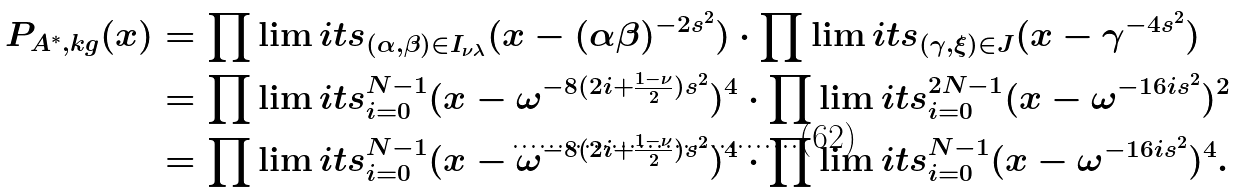Convert formula to latex. <formula><loc_0><loc_0><loc_500><loc_500>P _ { A ^ { \ast } , k g } ( x ) & = \prod \lim i t s _ { ( \alpha , \beta ) \in I _ { \nu \lambda } } ( x - ( \alpha \beta ) ^ { - 2 s ^ { 2 } } ) \cdot \prod \lim i t s _ { ( \gamma , \xi ) \in J } ( x - \gamma ^ { - 4 s ^ { 2 } } ) \\ & = \prod \lim i t s _ { i = 0 } ^ { N - 1 } ( x - \omega ^ { - 8 ( 2 i + \frac { 1 - \nu } { 2 } ) s ^ { 2 } } ) ^ { 4 } \cdot \prod \lim i t s _ { i = 0 } ^ { 2 N - 1 } ( x - \omega ^ { - 1 6 i s ^ { 2 } } ) ^ { 2 } \\ & = \prod \lim i t s _ { i = 0 } ^ { N - 1 } ( x - \omega ^ { - 8 ( 2 i + \frac { 1 - \nu } { 2 } ) s ^ { 2 } } ) ^ { 4 } \cdot \prod \lim i t s _ { i = 0 } ^ { N - 1 } ( x - \omega ^ { - 1 6 i s ^ { 2 } } ) ^ { 4 } .</formula> 